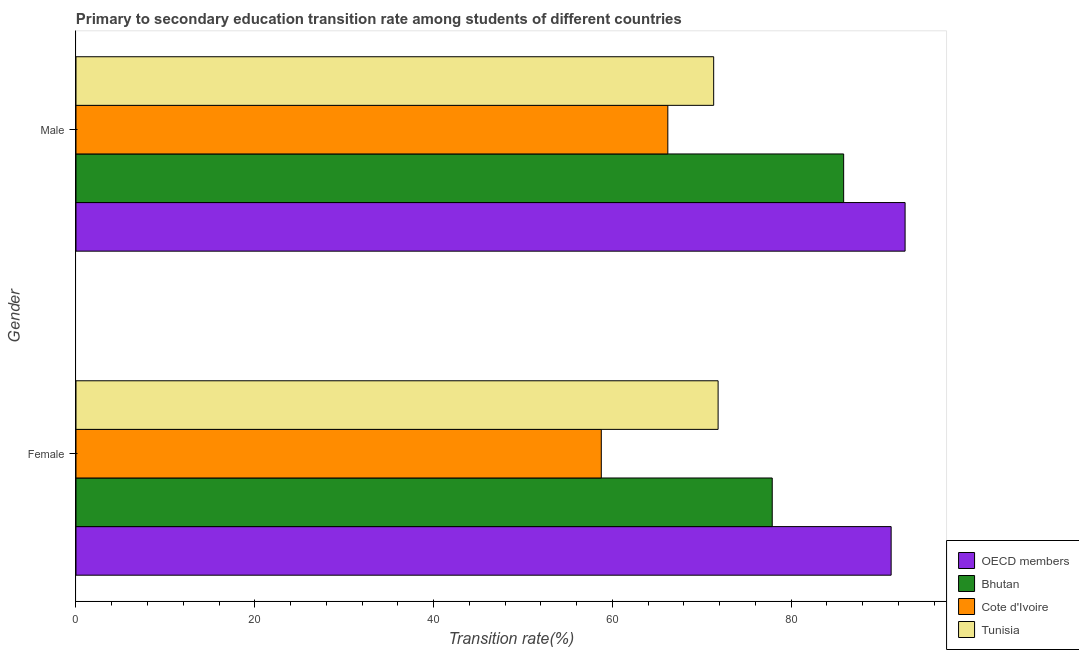How many different coloured bars are there?
Offer a terse response. 4. How many groups of bars are there?
Make the answer very short. 2. What is the label of the 2nd group of bars from the top?
Give a very brief answer. Female. What is the transition rate among female students in Cote d'Ivoire?
Make the answer very short. 58.77. Across all countries, what is the maximum transition rate among female students?
Provide a succinct answer. 91.19. Across all countries, what is the minimum transition rate among male students?
Keep it short and to the point. 66.21. In which country was the transition rate among female students minimum?
Offer a very short reply. Cote d'Ivoire. What is the total transition rate among male students in the graph?
Your response must be concise. 316.18. What is the difference between the transition rate among male students in OECD members and that in Tunisia?
Your response must be concise. 21.42. What is the difference between the transition rate among male students in Tunisia and the transition rate among female students in Cote d'Ivoire?
Your answer should be very brief. 12.57. What is the average transition rate among female students per country?
Give a very brief answer. 74.92. What is the difference between the transition rate among male students and transition rate among female students in Cote d'Ivoire?
Give a very brief answer. 7.44. What is the ratio of the transition rate among female students in Cote d'Ivoire to that in OECD members?
Your answer should be very brief. 0.64. Is the transition rate among male students in Cote d'Ivoire less than that in Bhutan?
Provide a short and direct response. Yes. In how many countries, is the transition rate among female students greater than the average transition rate among female students taken over all countries?
Your answer should be compact. 2. What does the 2nd bar from the top in Female represents?
Your answer should be very brief. Cote d'Ivoire. What is the difference between two consecutive major ticks on the X-axis?
Offer a terse response. 20. Are the values on the major ticks of X-axis written in scientific E-notation?
Your response must be concise. No. Does the graph contain any zero values?
Provide a succinct answer. No. Does the graph contain grids?
Your response must be concise. No. What is the title of the graph?
Your answer should be compact. Primary to secondary education transition rate among students of different countries. Does "Armenia" appear as one of the legend labels in the graph?
Your answer should be compact. No. What is the label or title of the X-axis?
Your answer should be compact. Transition rate(%). What is the Transition rate(%) of OECD members in Female?
Offer a terse response. 91.19. What is the Transition rate(%) of Bhutan in Female?
Your answer should be very brief. 77.89. What is the Transition rate(%) of Cote d'Ivoire in Female?
Offer a very short reply. 58.77. What is the Transition rate(%) of Tunisia in Female?
Ensure brevity in your answer.  71.83. What is the Transition rate(%) of OECD members in Male?
Provide a succinct answer. 92.75. What is the Transition rate(%) of Bhutan in Male?
Give a very brief answer. 85.88. What is the Transition rate(%) of Cote d'Ivoire in Male?
Provide a succinct answer. 66.21. What is the Transition rate(%) in Tunisia in Male?
Keep it short and to the point. 71.34. Across all Gender, what is the maximum Transition rate(%) in OECD members?
Your answer should be compact. 92.75. Across all Gender, what is the maximum Transition rate(%) in Bhutan?
Make the answer very short. 85.88. Across all Gender, what is the maximum Transition rate(%) of Cote d'Ivoire?
Your answer should be very brief. 66.21. Across all Gender, what is the maximum Transition rate(%) in Tunisia?
Your answer should be compact. 71.83. Across all Gender, what is the minimum Transition rate(%) of OECD members?
Provide a succinct answer. 91.19. Across all Gender, what is the minimum Transition rate(%) of Bhutan?
Provide a short and direct response. 77.89. Across all Gender, what is the minimum Transition rate(%) in Cote d'Ivoire?
Provide a succinct answer. 58.77. Across all Gender, what is the minimum Transition rate(%) of Tunisia?
Your answer should be very brief. 71.34. What is the total Transition rate(%) of OECD members in the graph?
Make the answer very short. 183.94. What is the total Transition rate(%) of Bhutan in the graph?
Provide a succinct answer. 163.77. What is the total Transition rate(%) in Cote d'Ivoire in the graph?
Your response must be concise. 124.97. What is the total Transition rate(%) in Tunisia in the graph?
Keep it short and to the point. 143.17. What is the difference between the Transition rate(%) in OECD members in Female and that in Male?
Offer a very short reply. -1.56. What is the difference between the Transition rate(%) in Bhutan in Female and that in Male?
Make the answer very short. -7.99. What is the difference between the Transition rate(%) in Cote d'Ivoire in Female and that in Male?
Your answer should be very brief. -7.44. What is the difference between the Transition rate(%) in Tunisia in Female and that in Male?
Provide a succinct answer. 0.5. What is the difference between the Transition rate(%) of OECD members in Female and the Transition rate(%) of Bhutan in Male?
Your answer should be compact. 5.31. What is the difference between the Transition rate(%) in OECD members in Female and the Transition rate(%) in Cote d'Ivoire in Male?
Ensure brevity in your answer.  24.98. What is the difference between the Transition rate(%) of OECD members in Female and the Transition rate(%) of Tunisia in Male?
Keep it short and to the point. 19.85. What is the difference between the Transition rate(%) in Bhutan in Female and the Transition rate(%) in Cote d'Ivoire in Male?
Your response must be concise. 11.68. What is the difference between the Transition rate(%) of Bhutan in Female and the Transition rate(%) of Tunisia in Male?
Offer a terse response. 6.55. What is the difference between the Transition rate(%) of Cote d'Ivoire in Female and the Transition rate(%) of Tunisia in Male?
Your answer should be very brief. -12.57. What is the average Transition rate(%) in OECD members per Gender?
Keep it short and to the point. 91.97. What is the average Transition rate(%) of Bhutan per Gender?
Ensure brevity in your answer.  81.88. What is the average Transition rate(%) in Cote d'Ivoire per Gender?
Your response must be concise. 62.49. What is the average Transition rate(%) in Tunisia per Gender?
Provide a short and direct response. 71.59. What is the difference between the Transition rate(%) in OECD members and Transition rate(%) in Bhutan in Female?
Give a very brief answer. 13.3. What is the difference between the Transition rate(%) of OECD members and Transition rate(%) of Cote d'Ivoire in Female?
Give a very brief answer. 32.43. What is the difference between the Transition rate(%) in OECD members and Transition rate(%) in Tunisia in Female?
Your answer should be compact. 19.36. What is the difference between the Transition rate(%) of Bhutan and Transition rate(%) of Cote d'Ivoire in Female?
Your answer should be very brief. 19.12. What is the difference between the Transition rate(%) of Bhutan and Transition rate(%) of Tunisia in Female?
Your response must be concise. 6.05. What is the difference between the Transition rate(%) of Cote d'Ivoire and Transition rate(%) of Tunisia in Female?
Provide a succinct answer. -13.07. What is the difference between the Transition rate(%) of OECD members and Transition rate(%) of Bhutan in Male?
Offer a very short reply. 6.87. What is the difference between the Transition rate(%) in OECD members and Transition rate(%) in Cote d'Ivoire in Male?
Your answer should be compact. 26.54. What is the difference between the Transition rate(%) of OECD members and Transition rate(%) of Tunisia in Male?
Provide a short and direct response. 21.42. What is the difference between the Transition rate(%) of Bhutan and Transition rate(%) of Cote d'Ivoire in Male?
Your response must be concise. 19.67. What is the difference between the Transition rate(%) in Bhutan and Transition rate(%) in Tunisia in Male?
Your answer should be compact. 14.54. What is the difference between the Transition rate(%) of Cote d'Ivoire and Transition rate(%) of Tunisia in Male?
Offer a very short reply. -5.13. What is the ratio of the Transition rate(%) of OECD members in Female to that in Male?
Provide a succinct answer. 0.98. What is the ratio of the Transition rate(%) of Bhutan in Female to that in Male?
Provide a succinct answer. 0.91. What is the ratio of the Transition rate(%) of Cote d'Ivoire in Female to that in Male?
Keep it short and to the point. 0.89. What is the difference between the highest and the second highest Transition rate(%) of OECD members?
Ensure brevity in your answer.  1.56. What is the difference between the highest and the second highest Transition rate(%) in Bhutan?
Your response must be concise. 7.99. What is the difference between the highest and the second highest Transition rate(%) in Cote d'Ivoire?
Offer a terse response. 7.44. What is the difference between the highest and the second highest Transition rate(%) in Tunisia?
Make the answer very short. 0.5. What is the difference between the highest and the lowest Transition rate(%) in OECD members?
Offer a terse response. 1.56. What is the difference between the highest and the lowest Transition rate(%) in Bhutan?
Give a very brief answer. 7.99. What is the difference between the highest and the lowest Transition rate(%) of Cote d'Ivoire?
Make the answer very short. 7.44. What is the difference between the highest and the lowest Transition rate(%) of Tunisia?
Your answer should be very brief. 0.5. 